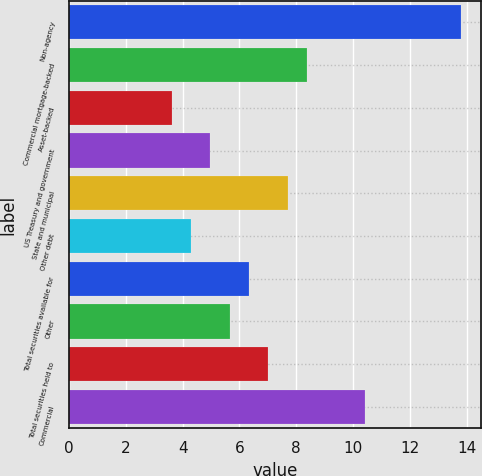<chart> <loc_0><loc_0><loc_500><loc_500><bar_chart><fcel>Non-agency<fcel>Commercial mortgage-backed<fcel>Asset-backed<fcel>US Treasury and government<fcel>State and municipal<fcel>Other debt<fcel>Total securities available for<fcel>Other<fcel>Total securities held to<fcel>Commercial<nl><fcel>13.81<fcel>8.37<fcel>3.61<fcel>4.97<fcel>7.69<fcel>4.29<fcel>6.33<fcel>5.65<fcel>7.01<fcel>10.41<nl></chart> 